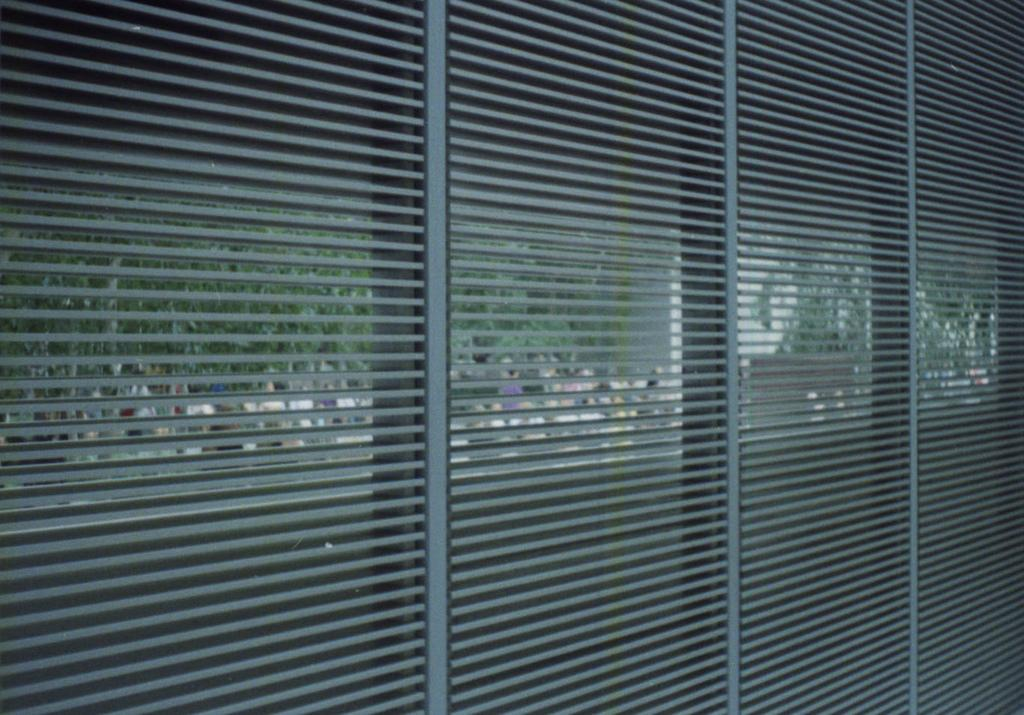What is present in the image that can be used to control the amount of light entering a room? There is a window blind in the image. What can be seen in the background of the image? Trees are visible in the background of the image. What is the color of the trees in the image? The trees are green in color. How many tails can be seen on the trees in the image? There are no tails present on the trees in the image, as trees do not have tails. What fact can be learned about the trees in the image? The fact that the trees are green in color can be learned from the image. 